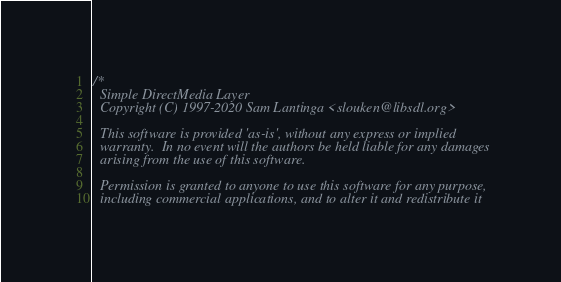<code> <loc_0><loc_0><loc_500><loc_500><_C_>/*
  Simple DirectMedia Layer
  Copyright (C) 1997-2020 Sam Lantinga <slouken@libsdl.org>

  This software is provided 'as-is', without any express or implied
  warranty.  In no event will the authors be held liable for any damages
  arising from the use of this software.

  Permission is granted to anyone to use this software for any purpose,
  including commercial applications, and to alter it and redistribute it</code> 